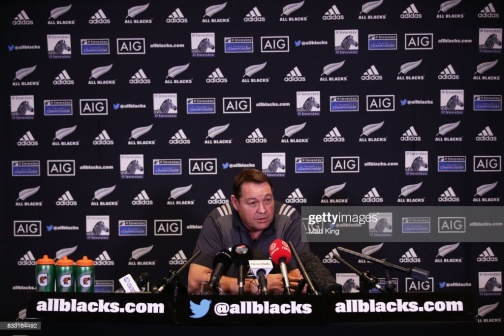Can you describe the person's role in this setting? The man in the image appears to play a significant role, likely a coach or a spokesperson for the rugby team, as suggested by the backdrop filled with All Blacks logos. His position at the center of attention, equipped with microphones and surrounded by media paraphernalia, indicates that he is responsible for communicating crucial information to the public and the press. His demeanor suggests confidence and familiarity with media interactions. What kind of event might this be? This looks like a press conference, perhaps taking place before or after an important rugby match involving the All Blacks. The presence of multiple microphones, the individual’s focused expression, and the array of logos on the backdrop all point to a well-organized media event. These conferences are typically held to discuss team performance, strategy, updates on player conditions, and to field questions from sports journalists. 